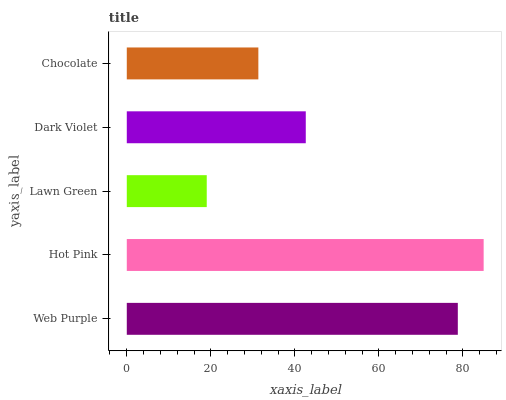Is Lawn Green the minimum?
Answer yes or no. Yes. Is Hot Pink the maximum?
Answer yes or no. Yes. Is Hot Pink the minimum?
Answer yes or no. No. Is Lawn Green the maximum?
Answer yes or no. No. Is Hot Pink greater than Lawn Green?
Answer yes or no. Yes. Is Lawn Green less than Hot Pink?
Answer yes or no. Yes. Is Lawn Green greater than Hot Pink?
Answer yes or no. No. Is Hot Pink less than Lawn Green?
Answer yes or no. No. Is Dark Violet the high median?
Answer yes or no. Yes. Is Dark Violet the low median?
Answer yes or no. Yes. Is Hot Pink the high median?
Answer yes or no. No. Is Lawn Green the low median?
Answer yes or no. No. 